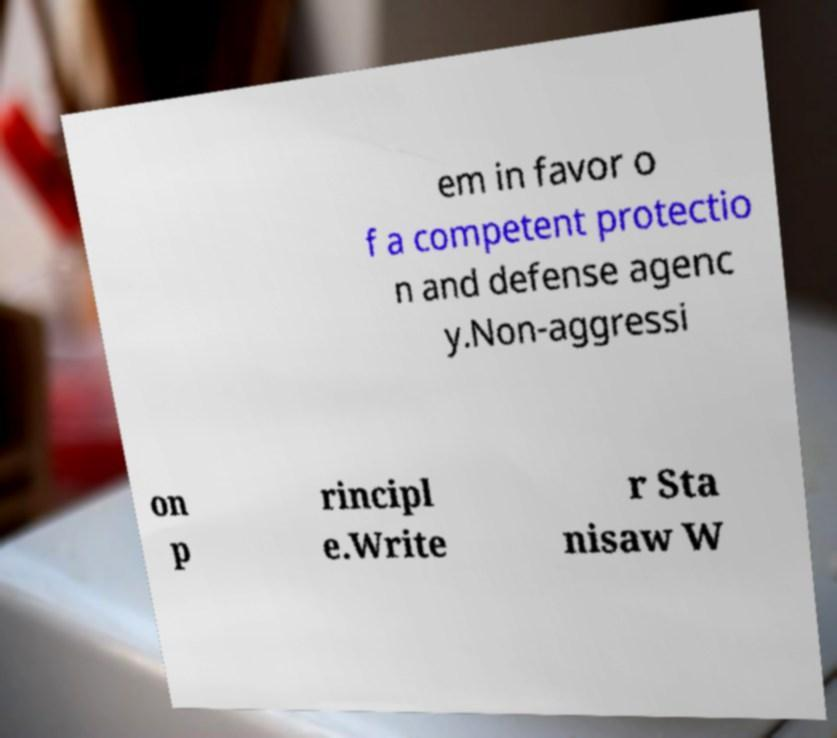There's text embedded in this image that I need extracted. Can you transcribe it verbatim? em in favor o f a competent protectio n and defense agenc y.Non-aggressi on p rincipl e.Write r Sta nisaw W 